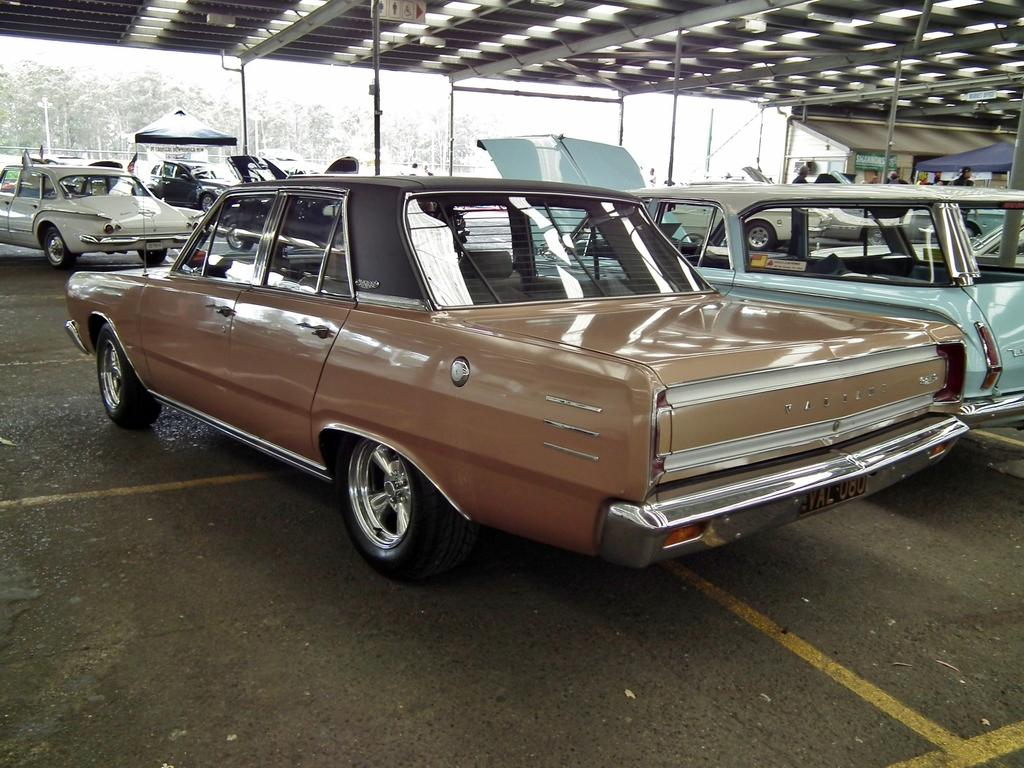What types of objects are present in the image? There are vehicles and canopy tents in the image. Can you describe the people in the image? There is a group of people in the image. What can be seen in the background of the image? There are trees in the background of the image. What type of needle can be seen in the image? There is no needle present in the image. What is the secretary doing in the image? There is no secretary present in the image. 